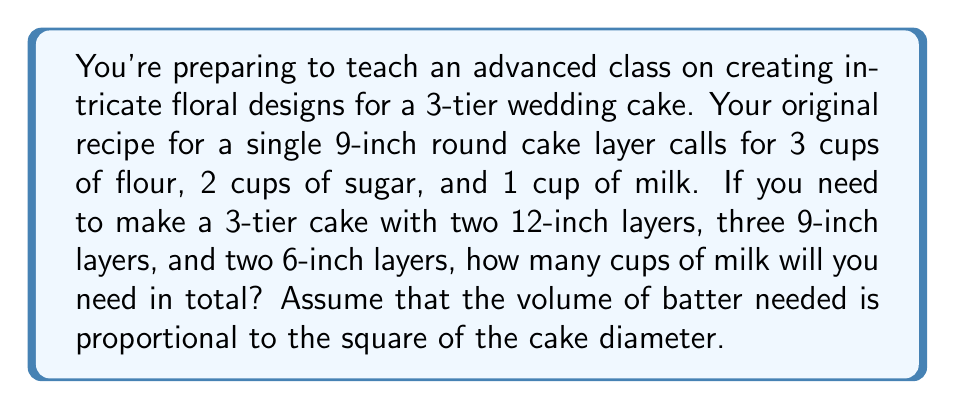Solve this math problem. Let's approach this step-by-step:

1) First, we need to determine the scaling factor for each cake size:
   - 12-inch cake: $(12/9)^2 = 16/9$
   - 9-inch cake: $(9/9)^2 = 1$ (no scaling needed)
   - 6-inch cake: $(6/9)^2 = 4/9$

2) Now, let's calculate the number of cups of milk needed for each tier:
   - 12-inch tier (2 layers): $2 \times (16/9) \times 1 = 32/9$ cups
   - 9-inch tier (3 layers): $3 \times 1 \times 1 = 3$ cups
   - 6-inch tier (2 layers): $2 \times (4/9) \times 1 = 8/9$ cups

3) Sum up the total:
   $$ \text{Total cups of milk} = \frac{32}{9} + 3 + \frac{8}{9} $$

4) Simplify:
   $$ \frac{32}{9} + \frac{27}{9} + \frac{8}{9} = \frac{67}{9} $$

5) Convert to a mixed number:
   $$ \frac{67}{9} = 7\frac{4}{9} $$

Therefore, you will need $7\frac{4}{9}$ cups of milk in total.
Answer: $7\frac{4}{9}$ cups 